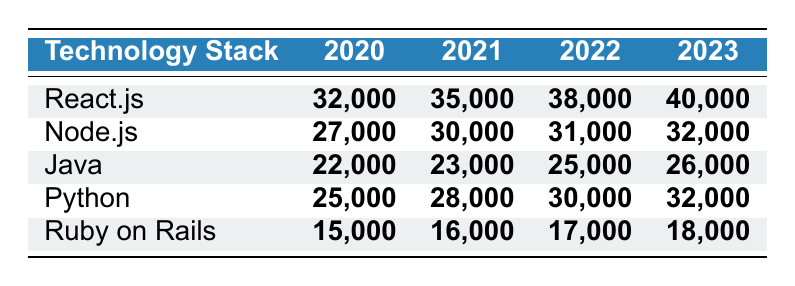What was the highest number of job postings for React.js? The table shows the job postings for React.js for each year: 32,000 in 2020, 35,000 in 2021, 38,000 in 2022, and 40,000 in 2023. The highest value in this column is 40,000 in 2023.
Answer: 40,000 Which technology stack had the lowest job postings in 2020? The table lists the job postings for each technology stack in 2020: React.js (32,000), Node.js (27,000), Java (22,000), Python (25,000), and Ruby on Rails (15,000). The lowest value is 15,000 for Ruby on Rails.
Answer: Ruby on Rails How many more job postings were there for Python in 2022 compared to 2020? For Python, the postings in 2020 were 25,000 and in 2022 were 30,000. The difference is calculated as 30,000 - 25,000 = 5,000.
Answer: 5,000 What is the total number of job postings for Java from 2020 to 2023? The postings for Java over the years are: 22,000 in 2020, 23,000 in 2021, 25,000 in 2022, and 26,000 in 2023. The total is 22,000 + 23,000 + 25,000 + 26,000 = 96,000.
Answer: 96,000 Did the job postings for Ruby on Rails increase every year from 2020 to 2023? The postings were 15,000 in 2020, 16,000 in 2021, 17,000 in 2022, and 18,000 in 2023. Since the postings increased each year, the answer is yes.
Answer: Yes Which technology stack had the largest growth in job postings from 2020 to 2023? Analyzing the postings for each technology: React.js went from 32,000 to 40,000 (+8,000), Node.js from 27,000 to 32,000 (+5,000), Java from 22,000 to 26,000 (+4,000), Python from 25,000 to 32,000 (+7,000), and Ruby on Rails from 15,000 to 18,000 (+3,000). The largest growth is 8,000 for React.js.
Answer: React.js What is the average number of job postings for Python over the four years? The postings for Python are 25,000 (2020), 28,000 (2021), 30,000 (2022), and 32,000 (2023). The average is calculated as (25,000 + 28,000 + 30,000 + 32,000) / 4 = 28,750.
Answer: 28,750 In which year did Node.js have more postings than Java? The postings for Node.js are: 27,000 in 2020, 30,000 in 2021, 31,000 in 2022, and 32,000 in 2023. The postings for Java are: 22,000 in 2020, 23,000 in 2021, 25,000 in 2022, and 26,000 in 2023. Node.js had more postings than Java in 2021, 2022, and 2023 but not in 2020.
Answer: 2021, 2022, 2023 What is the percentage increase of job postings for React.js from 2020 to 2023? The postings for React.js were 32,000 in 2020 and 40,000 in 2023. The percentage increase is calculated as ((40,000 - 32,000) / 32,000) * 100 = 25%.
Answer: 25% 